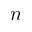<formula> <loc_0><loc_0><loc_500><loc_500>n</formula> 